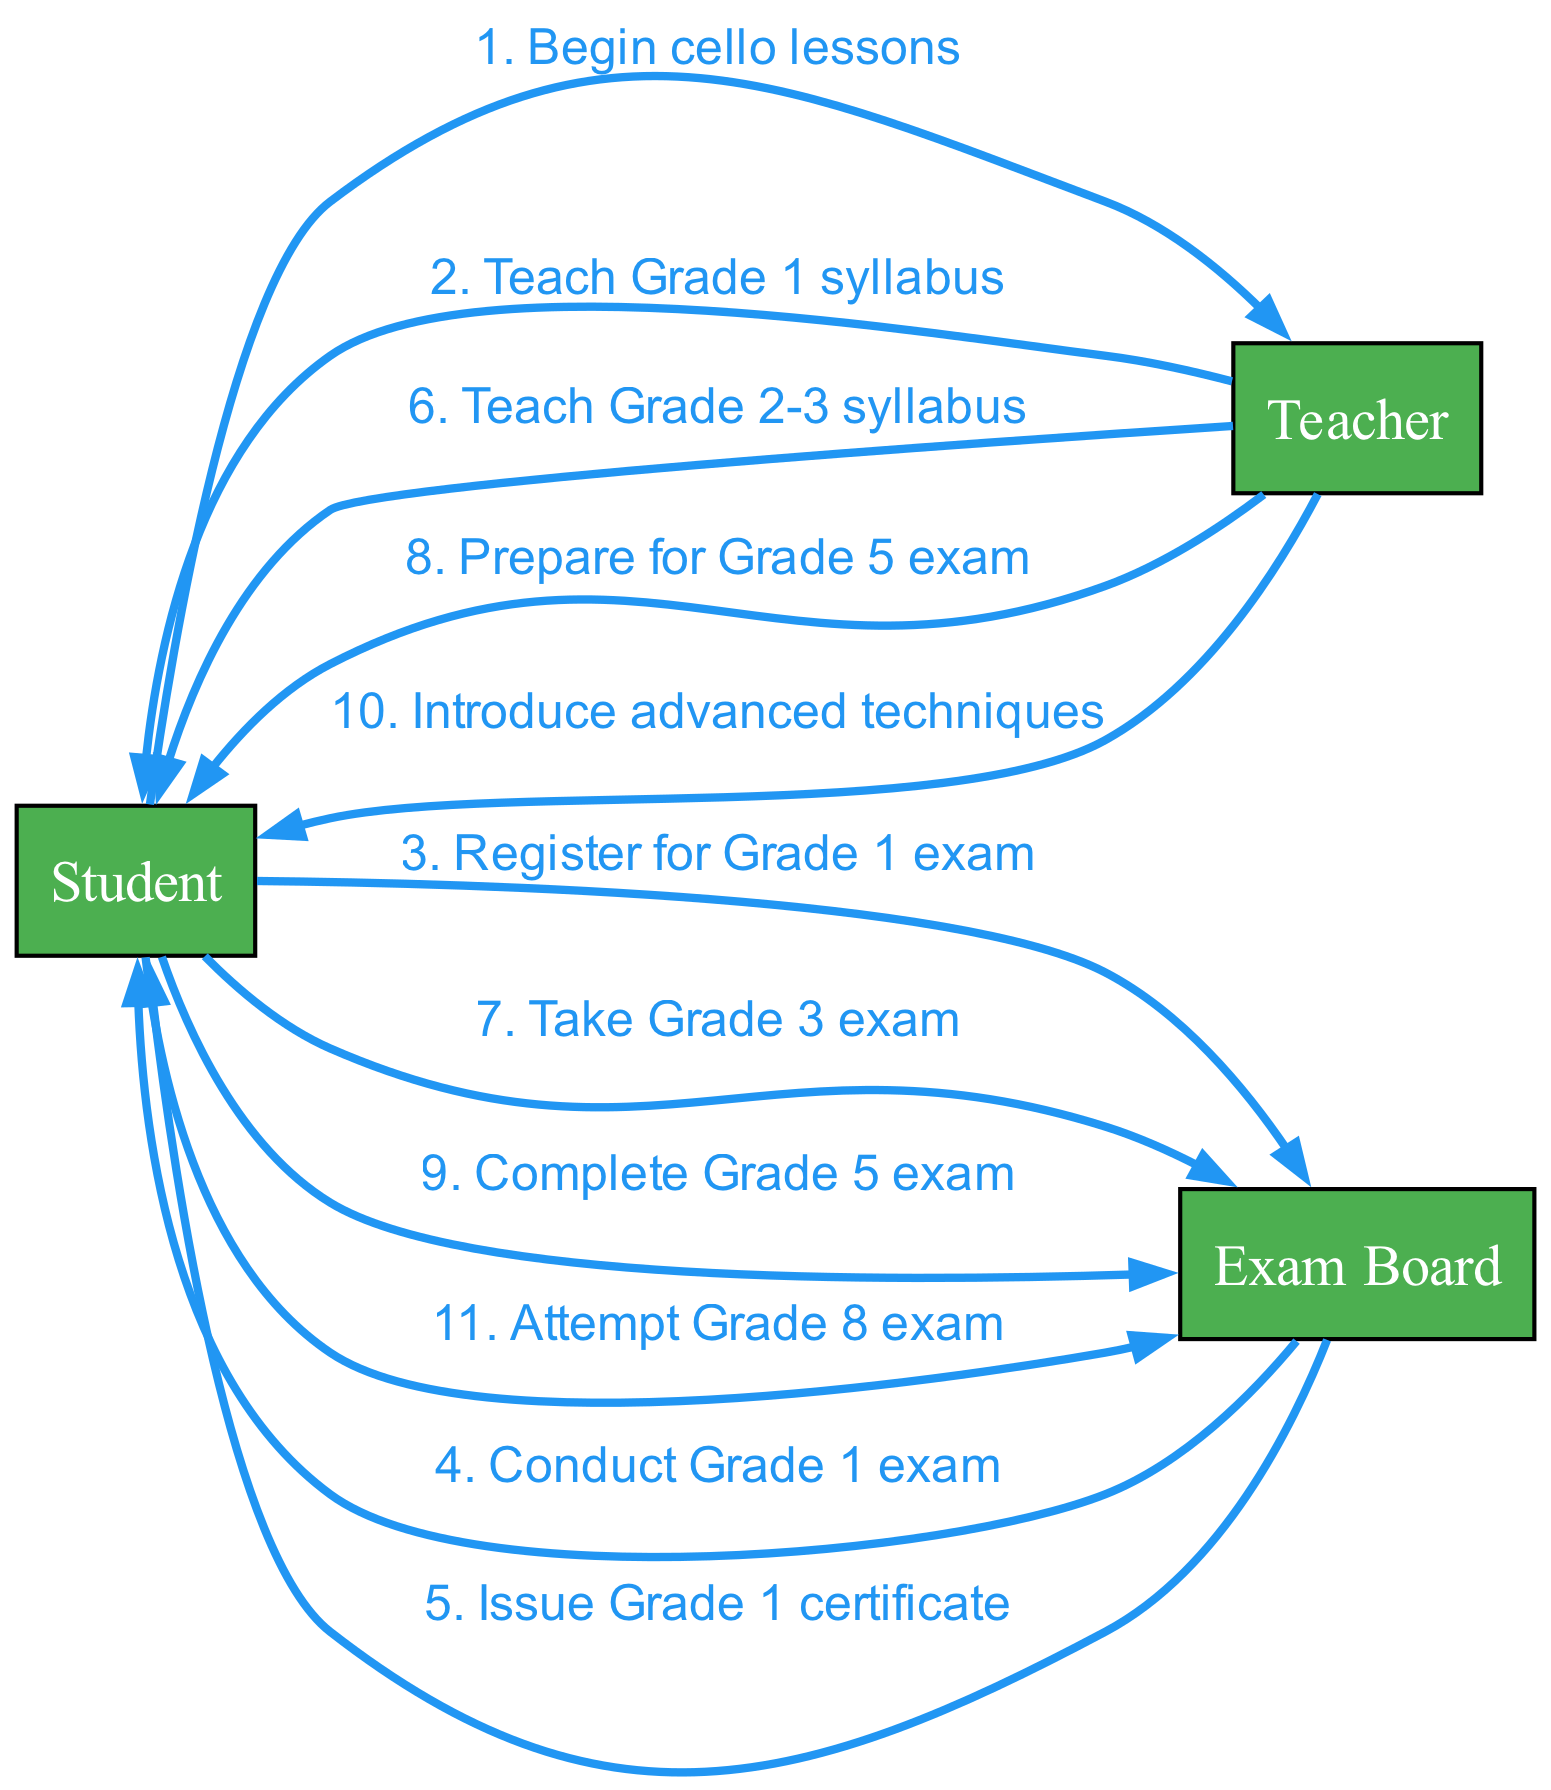What action follows after the student registers for the Grade 1 exam? After the student registers for the Grade 1 exam, the next action is the Exam Board conducting the Grade 1 exam. This can be traced directly in the sequence of actions that follow the registration.
Answer: Conduct Grade 1 exam How many grade levels are represented in the diagram? The diagram represents a total of four grade levels: Grade 1, Grade 2, Grade 3, and Grade 5. The sequence includes specific actions about teaching and exams for these grades.
Answer: Four What is the last action performed in the sequence? The last action in the sequence is the student attempting the Grade 8 exam. This is established by looking at the final entry in the sequence of actions.
Answer: Attempt Grade 8 exam Which actor teaches the student the Grade 2-3 syllabus? The actor that teaches the student the Grade 2-3 syllabus is the Teacher. This is identified in the specific action directed from the Teacher to the Student in the sequence.
Answer: Teacher How many times does the student interact with the Exam Board throughout the sequence? The student interacts with the Exam Board five times during the sequence: registering for Grade 1, taking the Grade 3 exam, completing the Grade 5 exam, and attempting the Grade 8 exam. This can be counted by reviewing each action in the sequence where the Student is involved with the Exam Board.
Answer: Five times What does the Teacher introduce after teaching the Grade 5 syllabus? After teaching the Grade 5 syllabus, the Teacher introduces advanced techniques. This is found by examining the flow of actions starting from the completion of the Grade 5 exam.
Answer: Introduce advanced techniques What action precedes the issuance of the Grade 1 certificate? The action that precedes the issuance of the Grade 1 certificate is the conduct of the Grade 1 exam by the Exam Board. Observing the sequence shows this direct relationship between the two actions.
Answer: Conduct Grade 1 exam Which grades are taught by the Teacher before preparing the student for the Grade 5 exam? The Teacher teaches the Grade 2-3 syllabus before preparing the student for the Grade 5 exam. This is identified by sequentially checking the actions performed by the Teacher related to the syllabus.
Answer: Grade 2-3 What is the overall progression of the student as indicated in the diagram? The overall progression of the student includes beginning cello lessons, advancing through grades 1 to 5, and ultimately attempting the Grade 8 exam. This can be understood by following the sequence of actions from start to finish.
Answer: Grades 1 to 8 